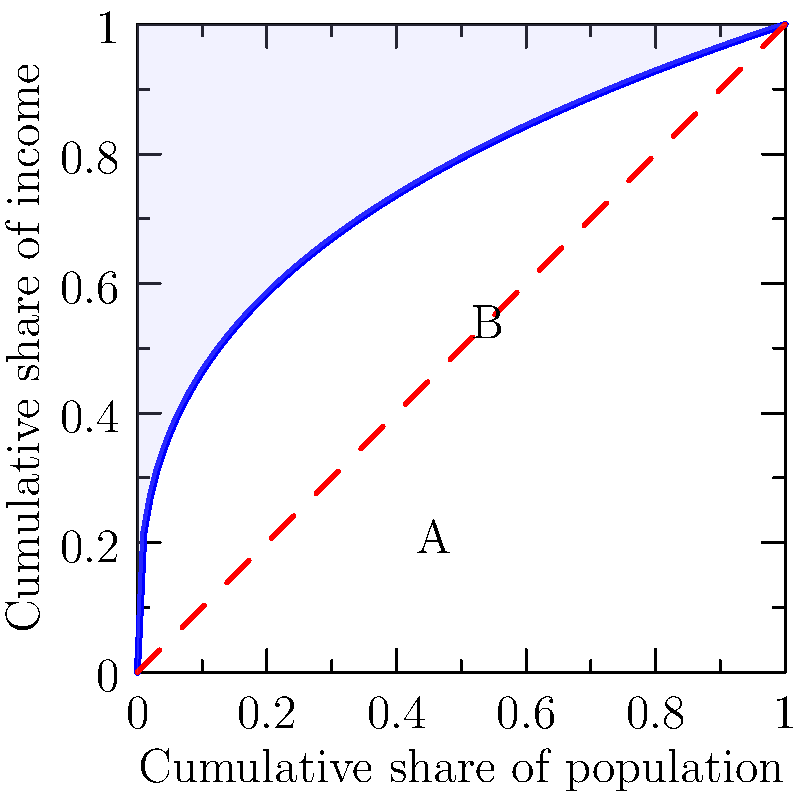In the context of wealth inequality, the Lorenz curve shown in the graph represents a society's income distribution. How does the shaded area A relate to the Gini coefficient, and what does this imply about the distribution of wealth in this society? Consider how this measure might be used or misused in discussions about human rights and economic justice. To answer this question, let's break it down step-by-step:

1. The Lorenz curve represents the cumulative share of income earned by the cumulative share of the population.

2. The line of equality (red dashed line) represents perfect income equality, where everyone earns the same amount.

3. The area between the line of equality and the Lorenz curve (shaded area A) represents the inequality in the income distribution.

4. The Gini coefficient is defined as:

   $$ \text{Gini coefficient} = \frac{\text{Area A}}{\text{Area A + Area B}} $$

5. In this case, Area A is the shaded region, and Area A + Area B represents the total area under the line of equality (a triangle with area 0.5).

6. The Gini coefficient ranges from 0 (perfect equality) to 1 (perfect inequality).

7. The larger the shaded area A, the higher the Gini coefficient, indicating greater inequality.

8. In this graph, area A is substantial, suggesting a relatively high Gini coefficient and significant income inequality.

9. From a human rights perspective, high inequality can be problematic as it may indicate unequal access to resources, opportunities, and basic needs.

10. However, the Gini coefficient alone doesn't provide a complete picture of economic justice. It doesn't account for factors such as social mobility, quality of life, or access to public services.

11. In discussions about human rights and economic justice, it's crucial to consider the Gini coefficient alongside other indicators and to question how wealth is generated and distributed in society.
Answer: The shaded area A is directly proportional to the Gini coefficient, indicating significant income inequality in this society. This measure, while useful, should be critically examined alongside other factors when discussing economic justice and human rights. 